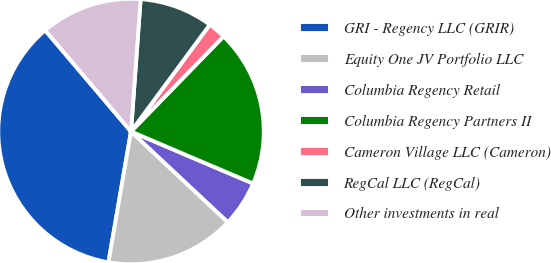Convert chart. <chart><loc_0><loc_0><loc_500><loc_500><pie_chart><fcel>GRI - Regency LLC (GRIR)<fcel>Equity One JV Portfolio LLC<fcel>Columbia Regency Retail<fcel>Columbia Regency Partners II<fcel>Cameron Village LLC (Cameron)<fcel>RegCal LLC (RegCal)<fcel>Other investments in real<nl><fcel>36.09%<fcel>15.74%<fcel>5.57%<fcel>19.13%<fcel>2.17%<fcel>8.96%<fcel>12.35%<nl></chart> 